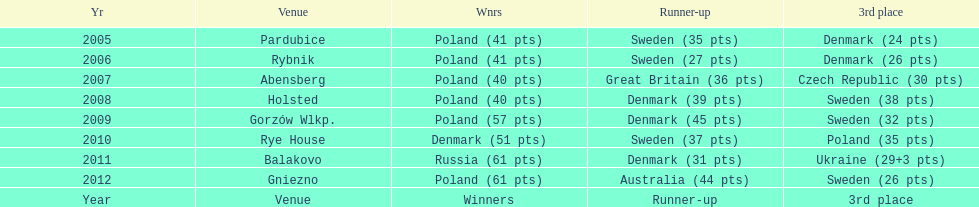What is the latest year in which the competitor finishing in 3rd place had under 25 points? 2005. 